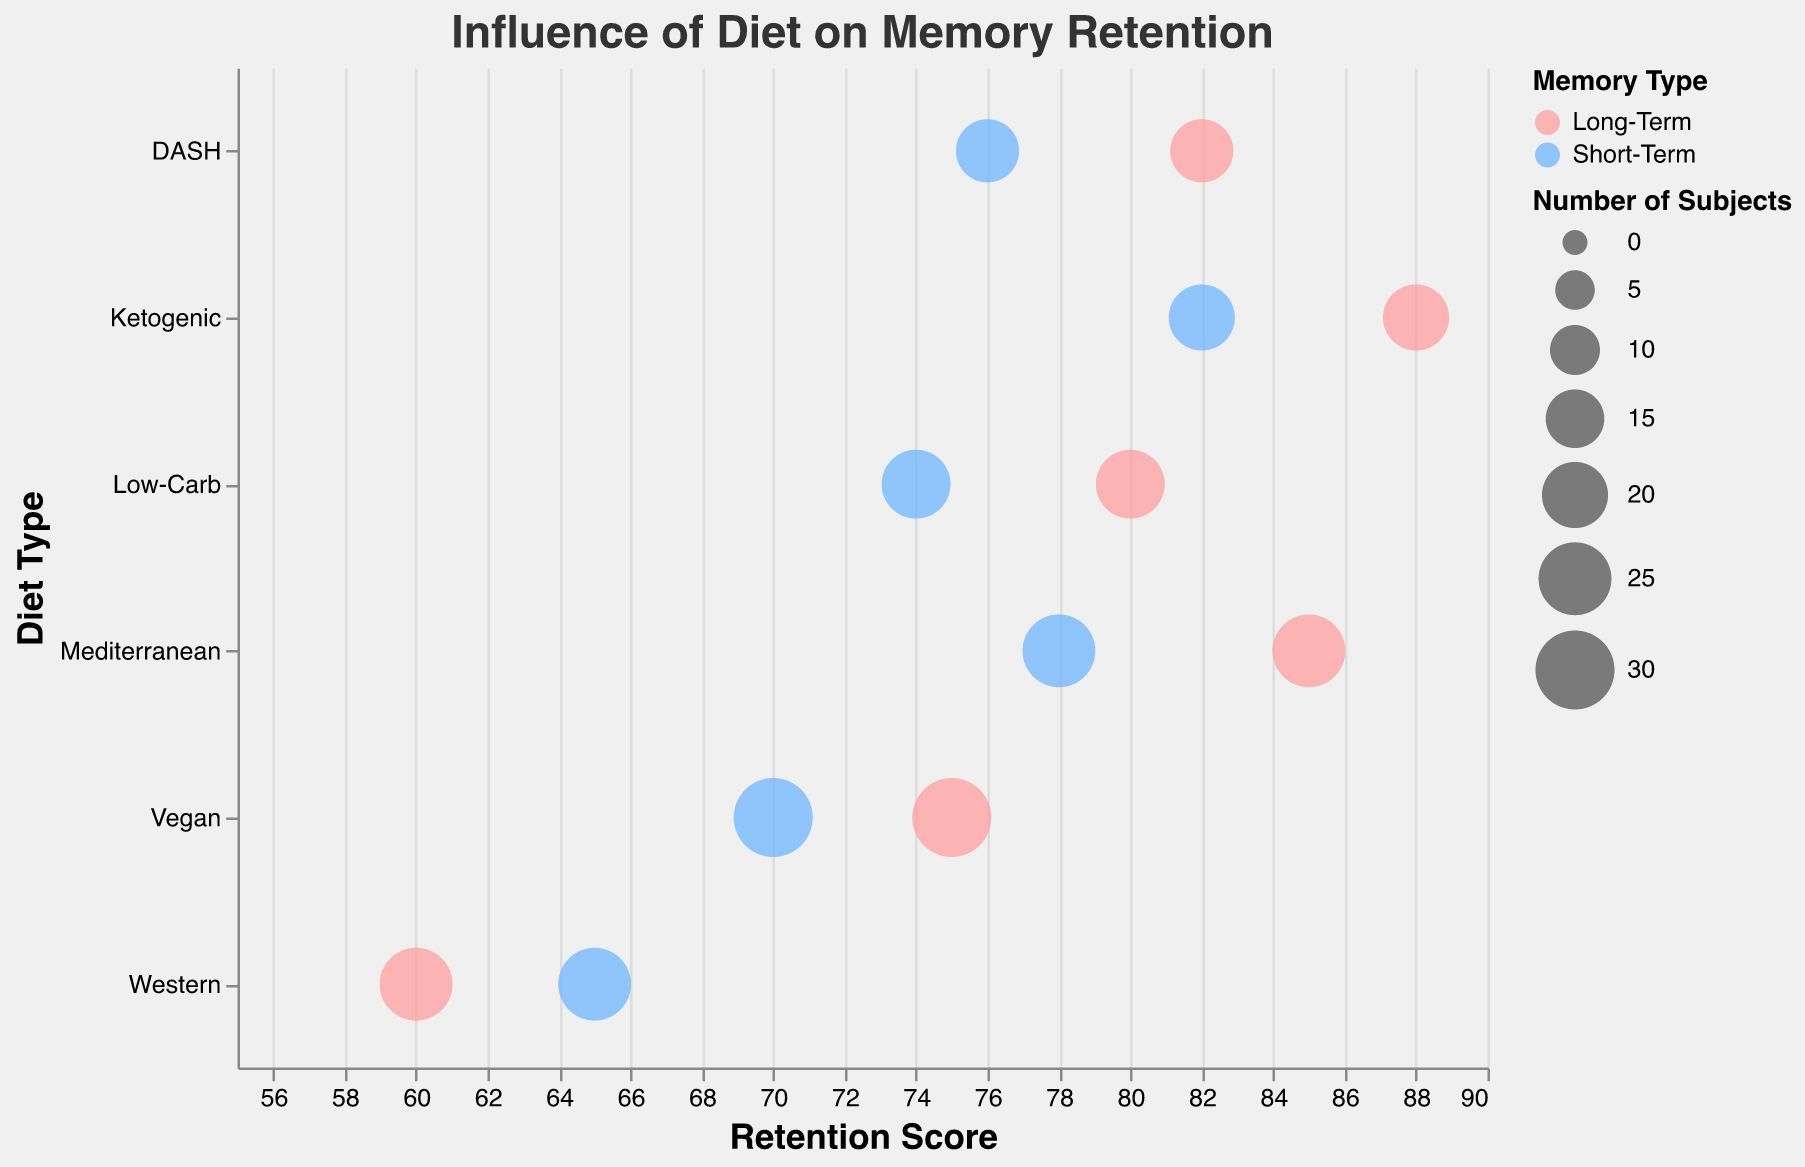What is the title of the figure? The title is a text element located at the top of the figure. Here, it reads "Influence of Diet on Memory Retention".
Answer: Influence of Diet on Memory Retention Which diet has the highest retention score for long-term memory? Look for the diet with the highest value in the Retention Score axis for the Long-Term Memory type. The Ketogenic diet has the highest score of 88 for long-term memory.
Answer: Ketogenic How does the retention score for short-term memory compare between the Western and Vegan diets? Find the Retention Score for Short-Term memory for both Western and Vegan diets. Western is 65 and Vegan is 70. Compare them and note that Vegan is higher.
Answer: Vegan (70) > Western (65) Which memory type is represented by blue bubbles? The legend explains the color representation of memory types. Blue bubbles represent Long-Term memory.
Answer: Long-Term What is the average retention score for Long-Term memory across all diets? Sum the retention scores for Long-Term memory across all diets: 85 (Mediterranean) + 60 (Western) + 88 (Ketogenic) + 75 (Vegan) + 80 (Low-Carb) + 82 (DASH) equals 470. There are 6 diets, so divide the sum by 6: 470 / 6 = 78.33
Answer: 78.33 Which diet has the smallest number of subjects, and what is the corresponding retention score for short-term memory? Look for the diet with the smallest circle size and check its tooltip. DASH diet has the smallest circle (18 subjects) for short-term memory with a score of 76.
Answer: DASH, 76 Compare the average ages of subjects in the DASH and Ketogenic diets. Which is higher? Check the Average_Age in the tooltip for both diets. DASH (29) and Ketogenic (30) show that Ketogenic diet has a higher average age.
Answer: Ketogenic (30) Which diet shows the biggest difference in retention scores between short-term and long-term memory? Calculate the difference in retention scores for each diet: Mediterranean (7), Western (5), Ketogenic (6), Vegan (5), Low-Carb (6), DASH (6). Mediterranean shows the biggest difference of 7.
Answer: Mediterranean What is the retention score for Long-Term memory in the Low-Carb diet? Look for the Low-Carb diet bubble colored blue and refer to its corresponding Retention Score.
Answer: 80 Which diet has an equal number of subjects for both Short-Term and Long-Term memory types? Find diet bubbles for both memory types with equal sized circles. Mediterranean and Western diets both have 25 subjects each.
Answer: Mediterranean, Western 